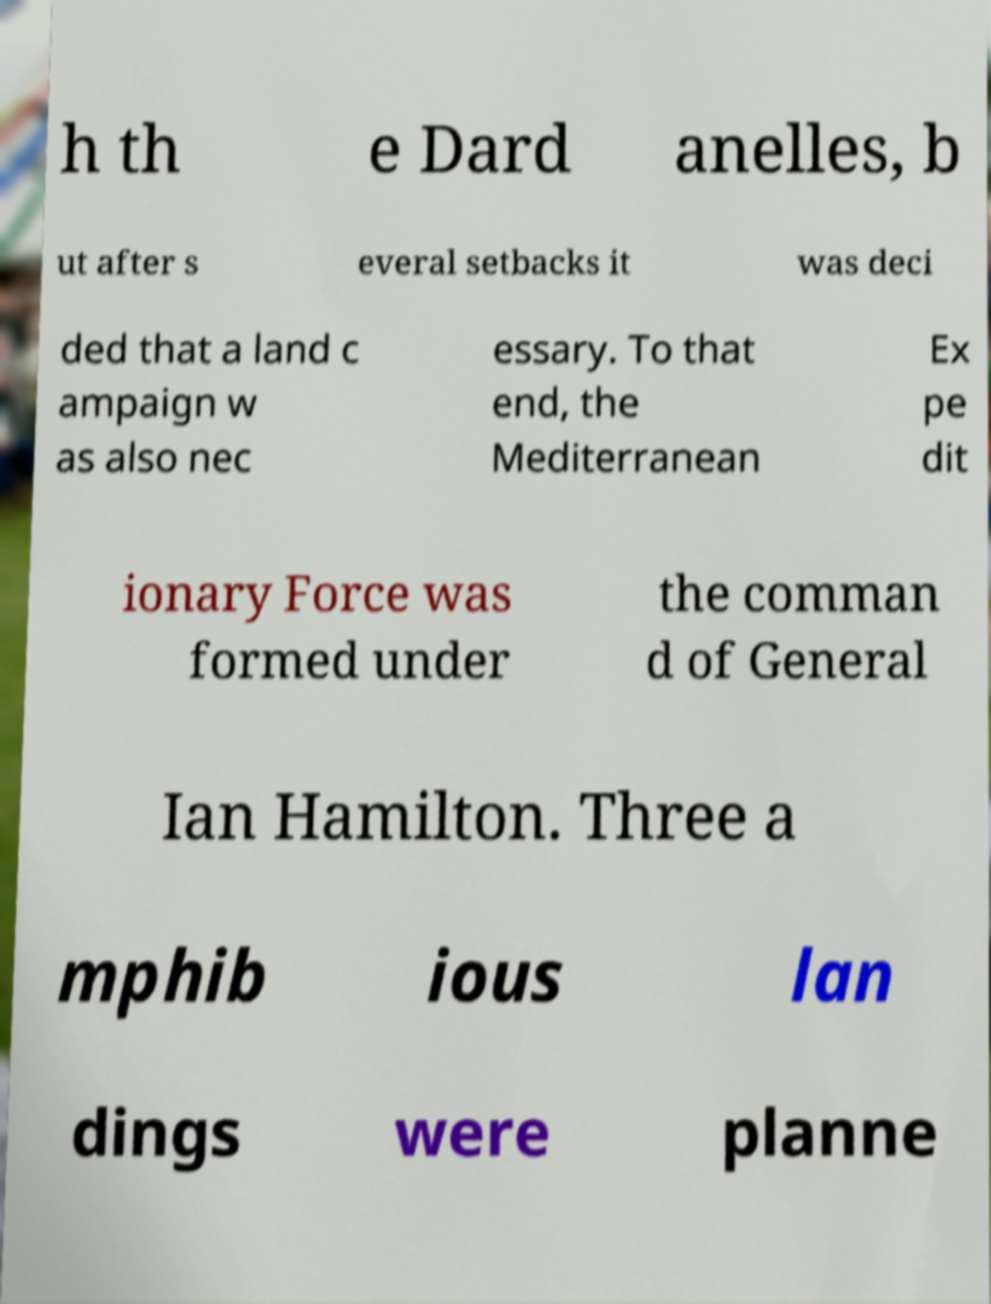Please read and relay the text visible in this image. What does it say? h th e Dard anelles, b ut after s everal setbacks it was deci ded that a land c ampaign w as also nec essary. To that end, the Mediterranean Ex pe dit ionary Force was formed under the comman d of General Ian Hamilton. Three a mphib ious lan dings were planne 